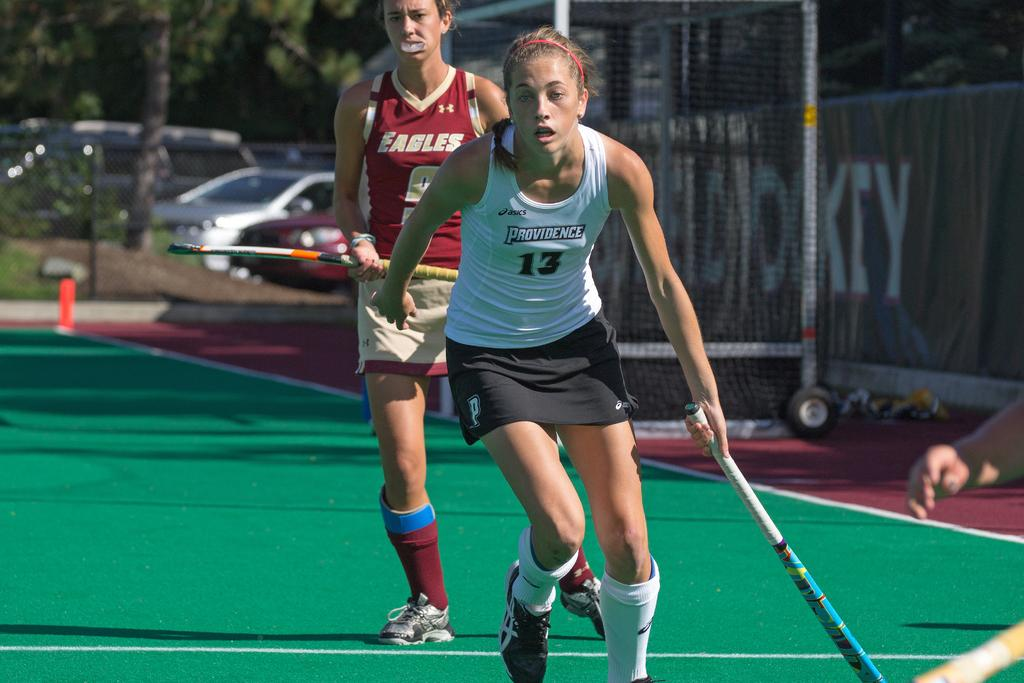<image>
Share a concise interpretation of the image provided. A woman wearing number 13 from Providence is playing field hockey. 